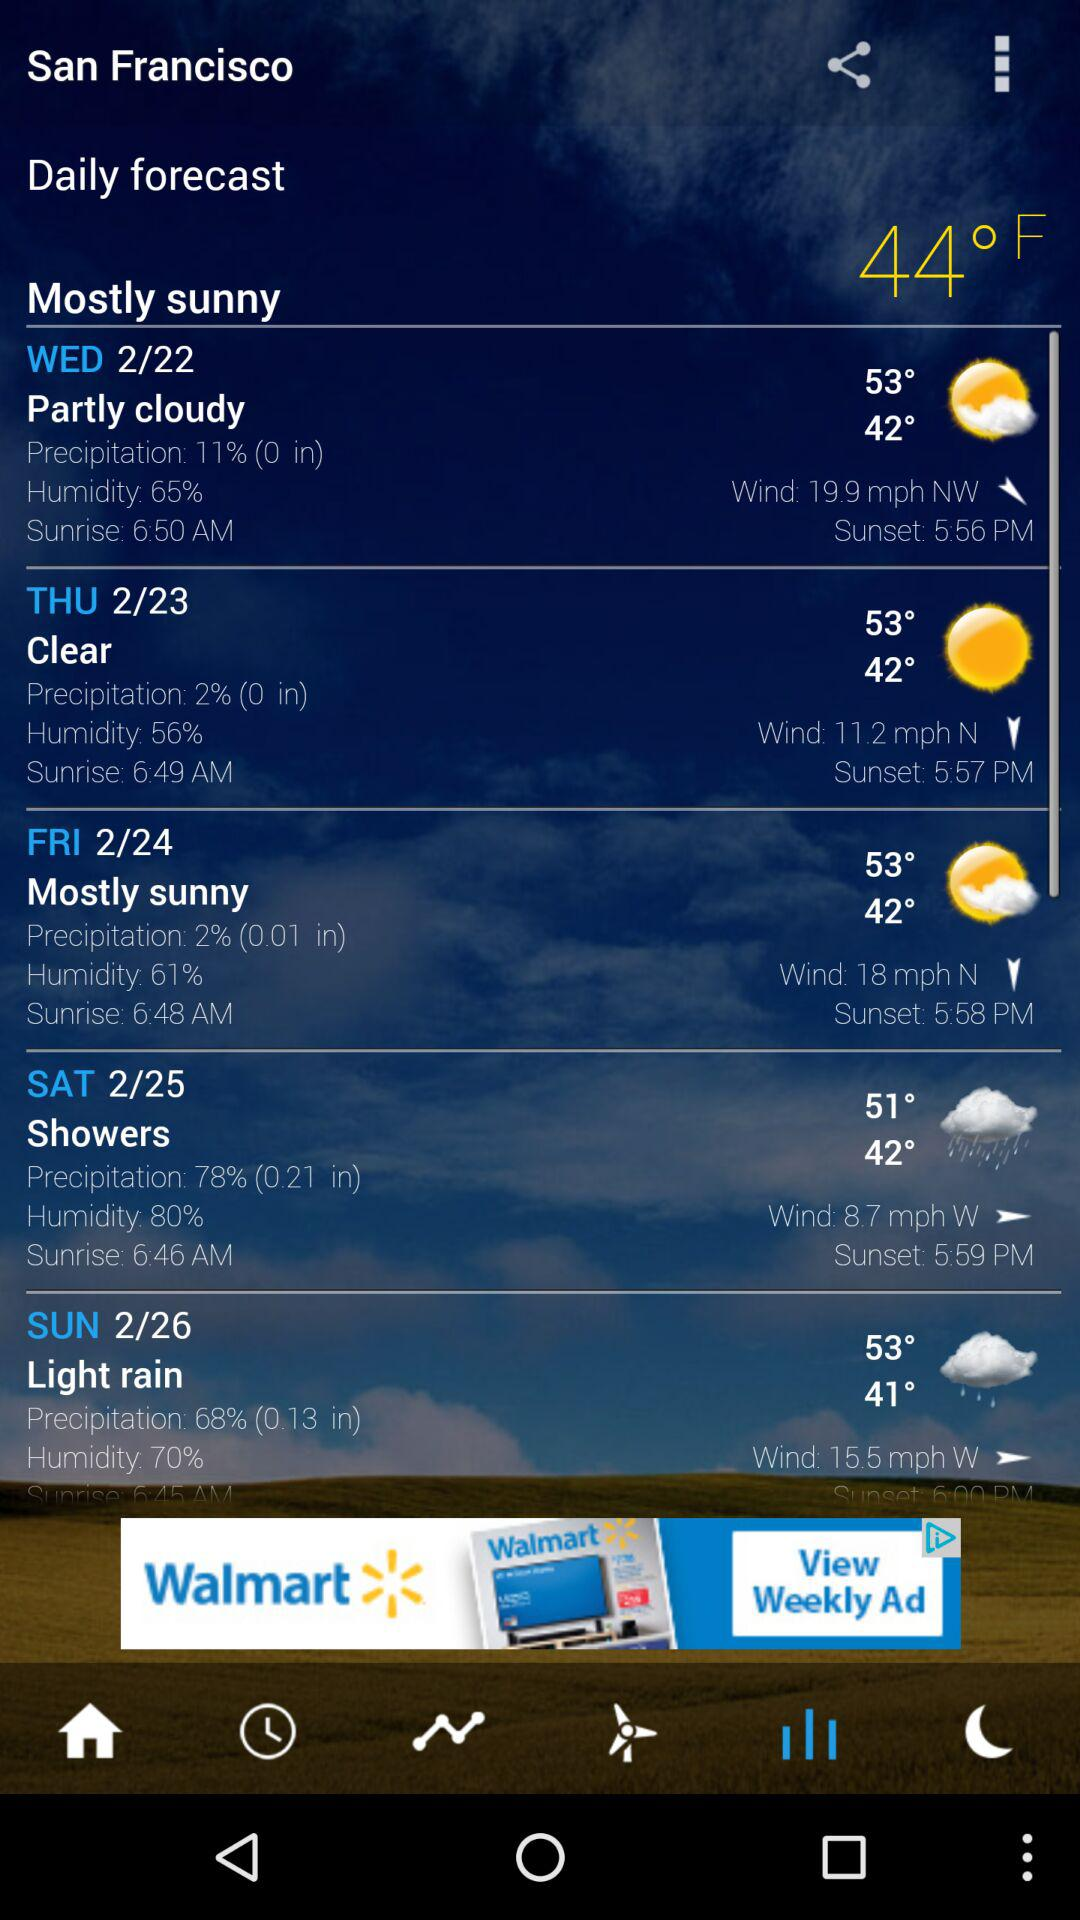How is the weather on Thursday in San Francisco? The weather is clear. 